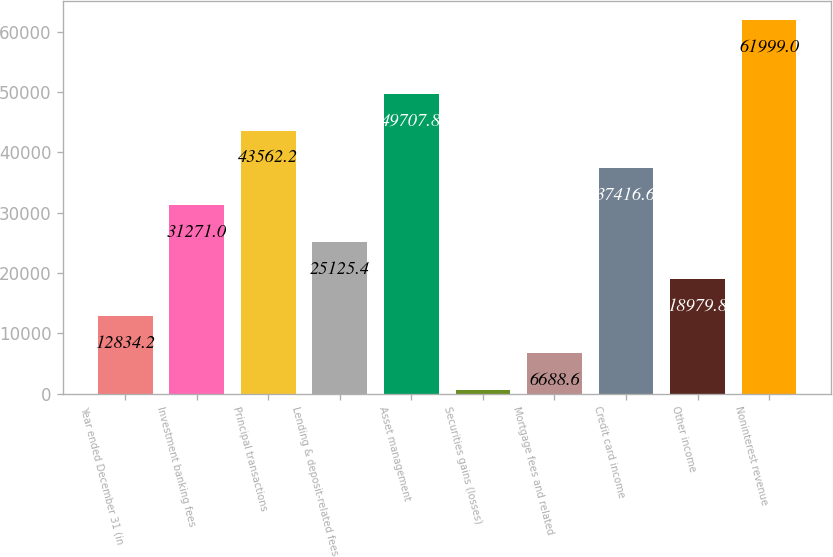Convert chart to OTSL. <chart><loc_0><loc_0><loc_500><loc_500><bar_chart><fcel>Year ended December 31 (in<fcel>Investment banking fees<fcel>Principal transactions<fcel>Lending & deposit-related fees<fcel>Asset management<fcel>Securities gains (losses)<fcel>Mortgage fees and related<fcel>Credit card income<fcel>Other income<fcel>Noninterest revenue<nl><fcel>12834.2<fcel>31271<fcel>43562.2<fcel>25125.4<fcel>49707.8<fcel>543<fcel>6688.6<fcel>37416.6<fcel>18979.8<fcel>61999<nl></chart> 